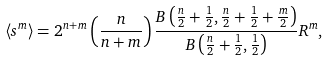<formula> <loc_0><loc_0><loc_500><loc_500>\left \langle s ^ { m } \right \rangle = 2 ^ { n + m } \left ( \frac { n } { n + m } \right ) \frac { B \left ( \frac { n } { 2 } + \frac { 1 } { 2 } , \frac { n } { 2 } + \frac { 1 } { 2 } + \frac { m } { 2 } \right ) } { B \left ( \frac { n } { 2 } + \frac { 1 } { 2 } , \frac { 1 } { 2 } \right ) } R ^ { m } ,</formula> 